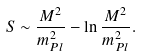<formula> <loc_0><loc_0><loc_500><loc_500>S \sim \frac { M ^ { 2 } } { m _ { P l } ^ { 2 } } - \ln \frac { M ^ { 2 } } { m _ { P l } ^ { 2 } } .</formula> 